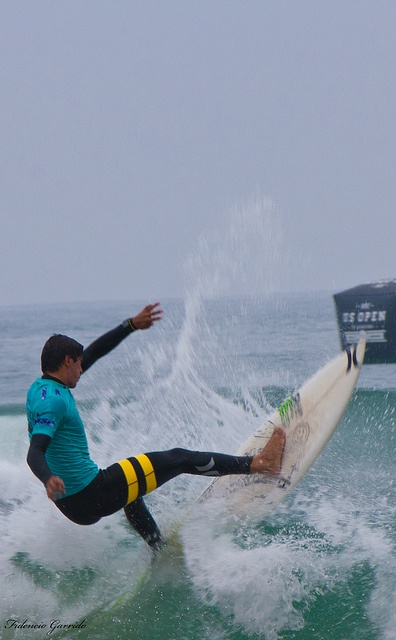Describe the objects in this image and their specific colors. I can see people in darkgray, black, teal, and gray tones and surfboard in darkgray, gray, and lightgray tones in this image. 